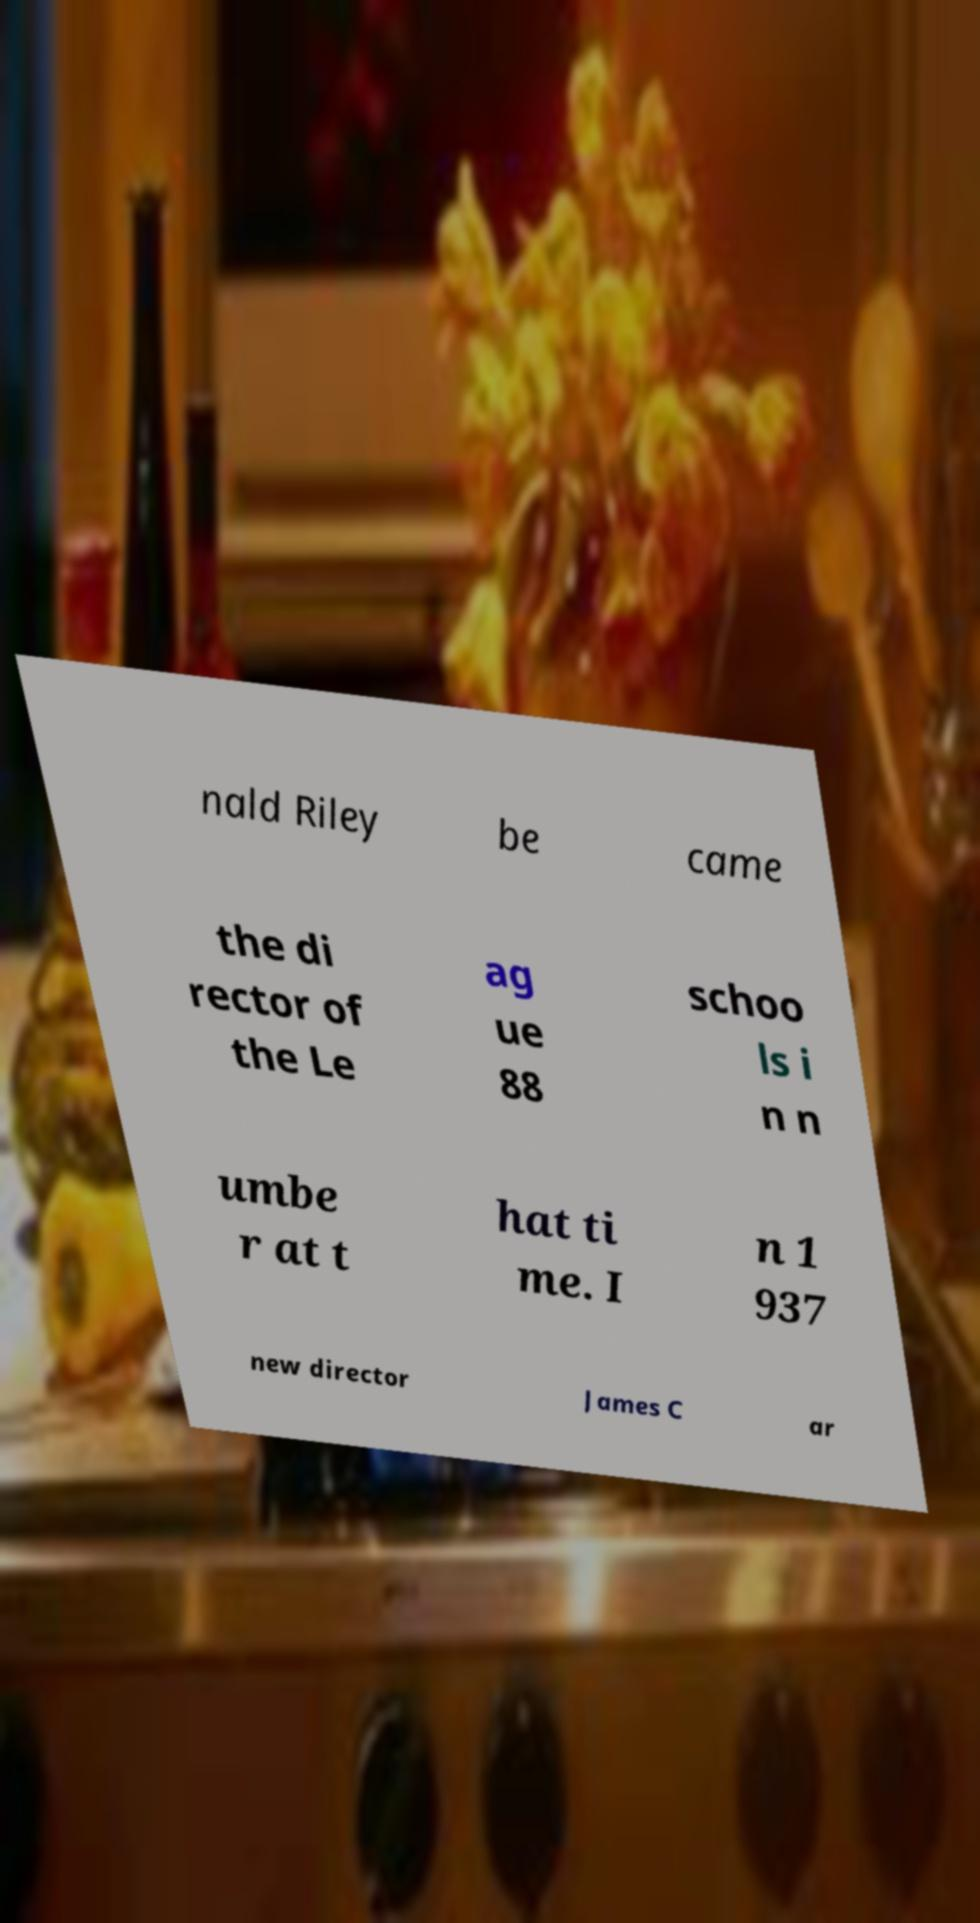There's text embedded in this image that I need extracted. Can you transcribe it verbatim? nald Riley be came the di rector of the Le ag ue 88 schoo ls i n n umbe r at t hat ti me. I n 1 937 new director James C ar 